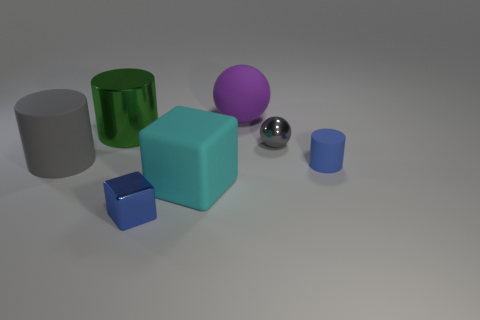What number of other objects are there of the same size as the gray ball? There are two objects that appear to be a similar size to the gray ball - a small blue cylinder and a small blue cube. 